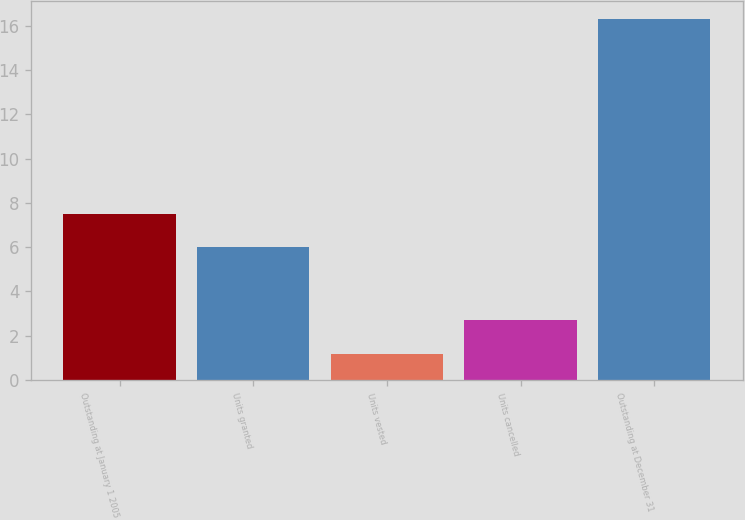Convert chart to OTSL. <chart><loc_0><loc_0><loc_500><loc_500><bar_chart><fcel>Outstanding at January 1 2005<fcel>Units granted<fcel>Units vested<fcel>Units cancelled<fcel>Outstanding at December 31<nl><fcel>7.51<fcel>6<fcel>1.2<fcel>2.71<fcel>16.3<nl></chart> 